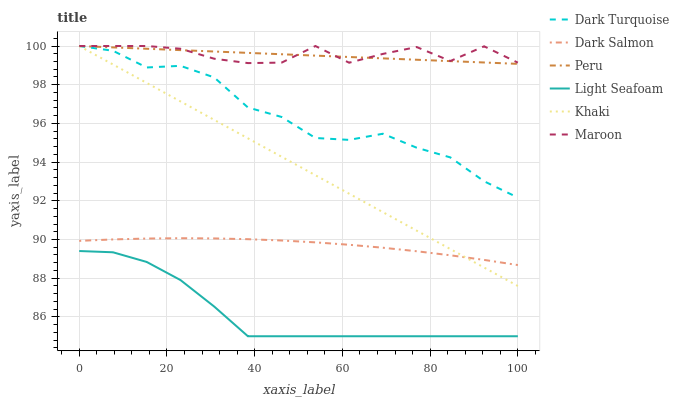Does Light Seafoam have the minimum area under the curve?
Answer yes or no. Yes. Does Maroon have the maximum area under the curve?
Answer yes or no. Yes. Does Dark Turquoise have the minimum area under the curve?
Answer yes or no. No. Does Dark Turquoise have the maximum area under the curve?
Answer yes or no. No. Is Khaki the smoothest?
Answer yes or no. Yes. Is Maroon the roughest?
Answer yes or no. Yes. Is Dark Turquoise the smoothest?
Answer yes or no. No. Is Dark Turquoise the roughest?
Answer yes or no. No. Does Light Seafoam have the lowest value?
Answer yes or no. Yes. Does Dark Turquoise have the lowest value?
Answer yes or no. No. Does Peru have the highest value?
Answer yes or no. Yes. Does Dark Salmon have the highest value?
Answer yes or no. No. Is Light Seafoam less than Maroon?
Answer yes or no. Yes. Is Maroon greater than Light Seafoam?
Answer yes or no. Yes. Does Maroon intersect Dark Turquoise?
Answer yes or no. Yes. Is Maroon less than Dark Turquoise?
Answer yes or no. No. Is Maroon greater than Dark Turquoise?
Answer yes or no. No. Does Light Seafoam intersect Maroon?
Answer yes or no. No. 